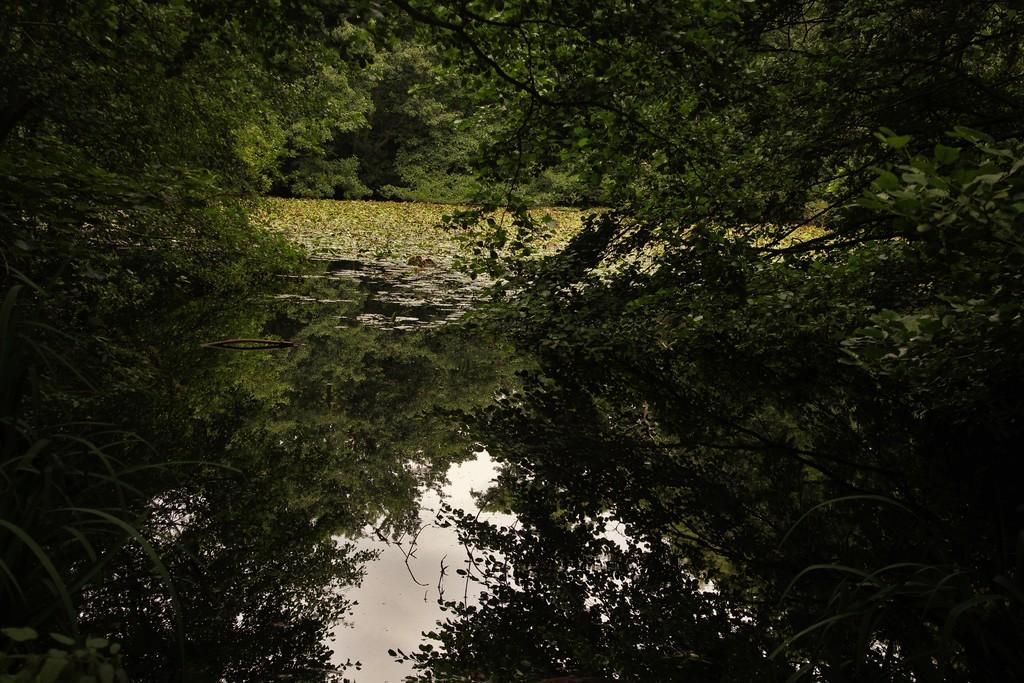What is the primary element visible in the image? There is water in the image. What is floating on the water? There are many leaves on the water. What type of vegetation can be seen in the image? There are trees visible in the image. What type of jewel can be seen hanging from the leaves in the image? There are no jewels present in the image; it features water with leaves and trees. What type of coat is the tree wearing in the image? Trees do not wear coats; they have bark and leaves as their natural covering. 